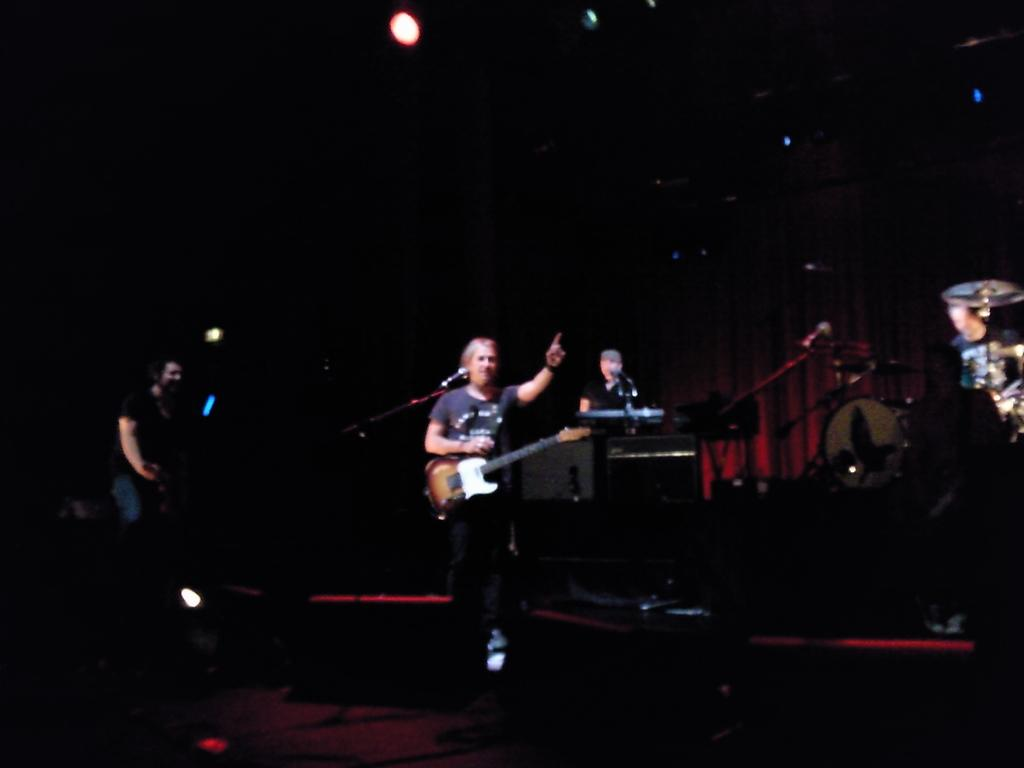What is the man in the image holding? The man in the image is holding a guitar. What is the gender of the person holding the guitar? The person holding the guitar is a man. What other musical instruments are present in the image? There are drums in the image. Where are the people playing the musical instruments positioned in relation to the man holding the guitar? The people playing the musical instruments are on either side of the man holding the guitar. What type of police vehicle can be seen in the image? There is no police vehicle present in the image. How does the railway track affect the musical performance in the image? There is no railway track present in the image, so it does not affect the musical performance. 